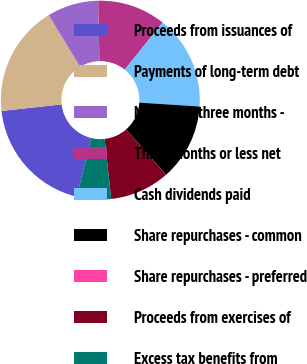Convert chart to OTSL. <chart><loc_0><loc_0><loc_500><loc_500><pie_chart><fcel>Proceeds from issuances of<fcel>Payments of long-term debt<fcel>More than three months -<fcel>Three months or less net<fcel>Cash dividends paid<fcel>Share repurchases - common<fcel>Share repurchases - preferred<fcel>Proceeds from exercises of<fcel>Excess tax benefits from<nl><fcel>19.44%<fcel>18.05%<fcel>8.34%<fcel>11.11%<fcel>15.27%<fcel>12.5%<fcel>0.01%<fcel>9.72%<fcel>5.56%<nl></chart> 